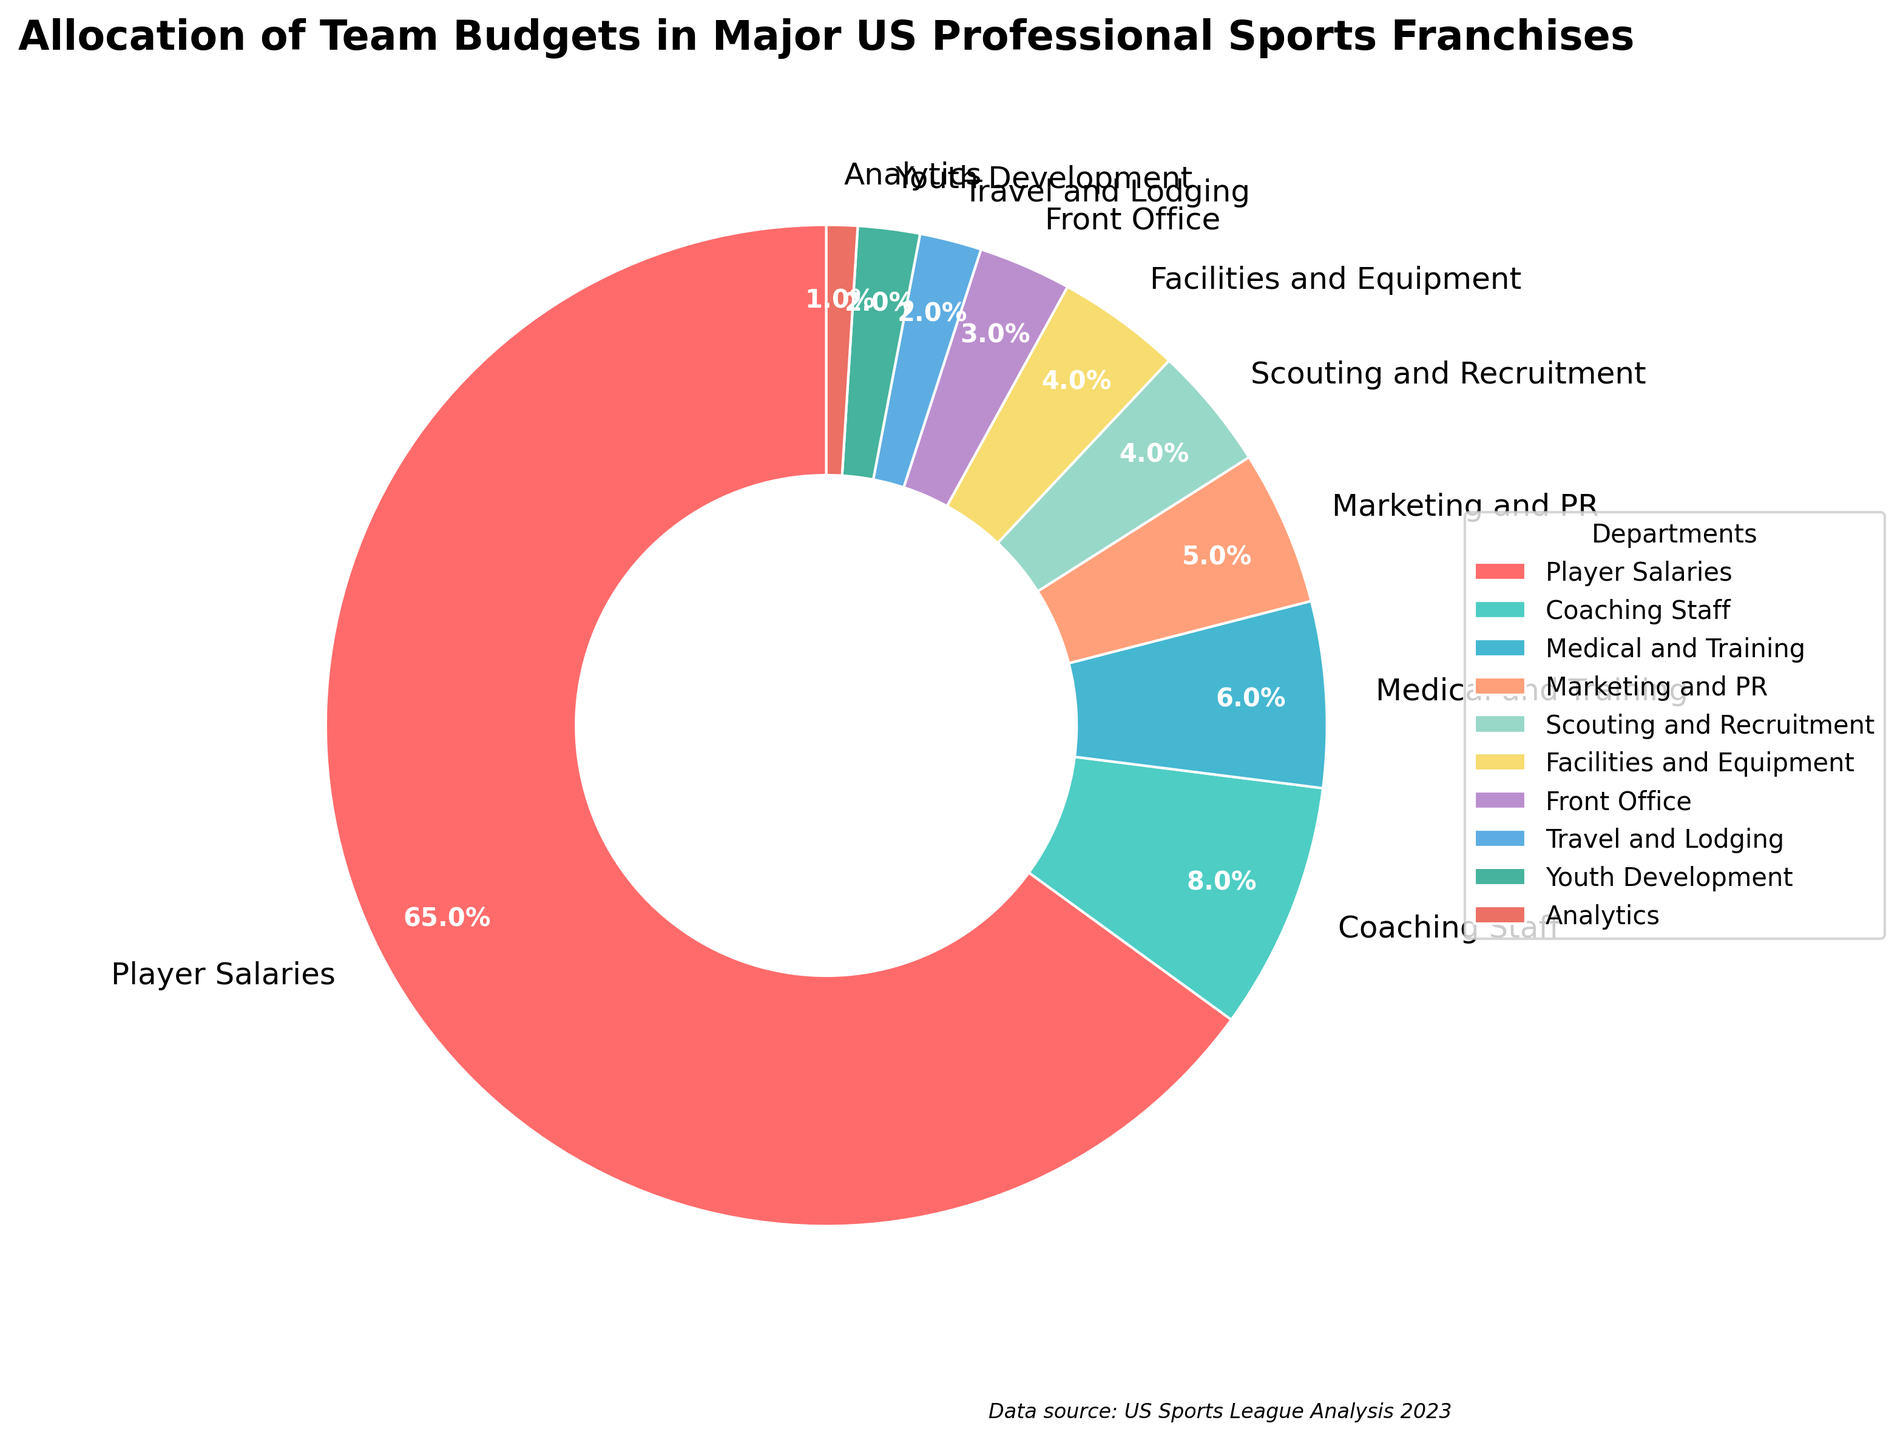Which department receives the largest allocation of budget? By examining the pie chart, the slice for Player Salaries is the largest.
Answer: Player Salaries What percentage of the budget is allocated to departments other than Player Salaries? Calculate by subtracting Player Salaries’ percentage from 100%: 100% - 65% = 35%.
Answer: 35% How much more budget is allocated to Player Salaries compared to Coaching Staff? Calculate the difference between the percentages of Player Salaries and Coaching Staff: 65% - 8% = 57%.
Answer: 57% What is the total percentage of budget allocation for Youth Development, Analytics, and Travel and Lodging combined? Sum the percentages: 2% + 1% + 2% = 5%.
Answer: 5% If you compare the budgets for Scouting and Recruitment with Medical and Training, which one is higher and by how much? Medical and Training has a higher percentage than Scouting and Recruitment. Calculate the difference: 6% - 4% = 2%.
Answer: Medical and Training; 2% Which departments receive a budget allocation of less than 5% each? From the pie chart, departments with less than 5% allocation are Scouting and Recruitment, Facilities and Equipment, Front Office, Travel and Lodging, Youth Development, and Analytics.
Answer: Scouting and Recruitment, Facilities and Equipment, Front Office, Travel and Lodging, Youth Development, Analytics How does the budget for Marketing and PR compare to that of Medical and Training? The budget allocation for Marketing and PR is 5%, whereas for Medical and Training it is 6%. So, Medical and Training has 1% more budget.
Answer: Medical and Training; 1% Which slice is colored in red, and what is its percentage allocation? The pie chart's red slice represents Player Salaries, which has a 65% allocation.
Answer: Player Salaries; 65% In the allocation, which department has the smallest share and what color represents it? The smallest share in the allocation is for Analytics, with a 1% budget, and it is colored in a greenish tone.
Answer: Analytics; greenish 